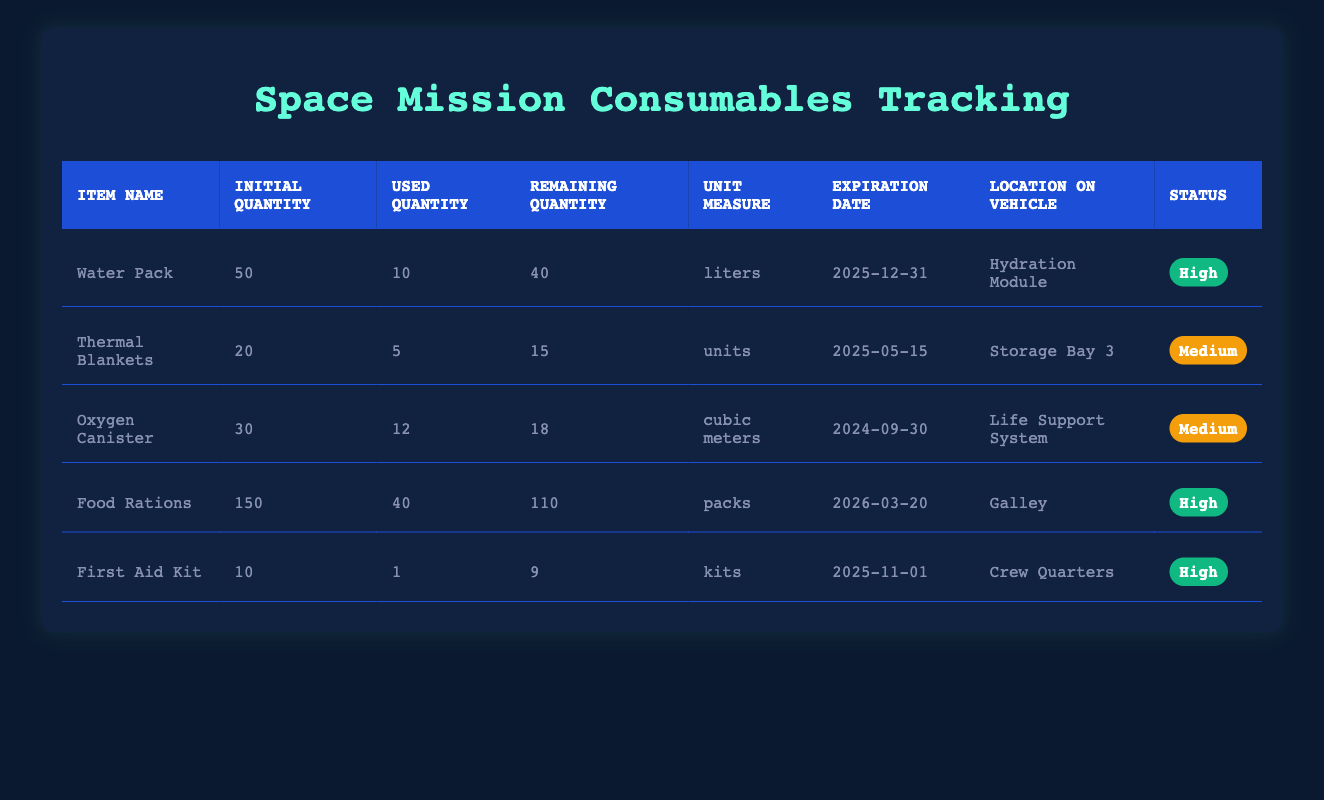What is the remaining quantity of Food Rations? The table shows that the remaining quantity of Food Rations is listed under the appropriate column, which indicates that there are 110 packs of Food Rations left.
Answer: 110 packs How many liters of Water Pack have been used? By referring to the table, the used quantity for Water Pack is directly indicated as 10 liters.
Answer: 10 liters Is the expiration date of the First Aid Kit before the expiration date of the Thermal Blankets? The expiration date for the First Aid Kit is 2025-11-01 and for Thermal Blankets it is 2025-05-15. Since 2025-11-01 is after 2025-05-15, the statement is false.
Answer: No What is the total number of used Thermal Blankets and First Aid Kits? The used quantities for Thermal Blankets and First Aid Kits are 5 and 1 respectively. Adding them together gives 5 + 1 = 6 units.
Answer: 6 units Does the Oxygen Canister have a higher initial quantity than the Water Pack? The table indicates that Oxygen Canister has an initial quantity of 30 while Water Pack has 50. Therefore, the statement is false.
Answer: No What is the total remaining quantity of consumables that have a high status? The total remaining quantities for high status items (Water Pack, Food Rations, and First Aid Kit) are 40, 110, and 9 respectively. Adding these gives 40 + 110 + 9 = 159.
Answer: 159 units Which item has the highest initial quantity? Reviewing the initial quantities, Food Rations has the highest initial quantity at 150 packs compared to the others.
Answer: 150 packs What is the average consumption rate per day of the consumables? The consumption rates are 2 for Water Pack and 1.5 for Oxygen Canister. Thermal Blankets, Food Rations, and First Aid Kit do not have rates listed. Average calculation is (2 + 1.5) / 2 = 1.25.
Answer: 1.25 liters/cubic meters How many more units of Thermal Blankets need to be used before they reach low status? The remaining quantity before reaching low status is calculated as follows: the low threshold would be defined as 5 or fewer units remaining. Currently, there are 15 units remaining, therefore 15 - 5 = 10 units can be used before reaching low status.
Answer: 10 units 